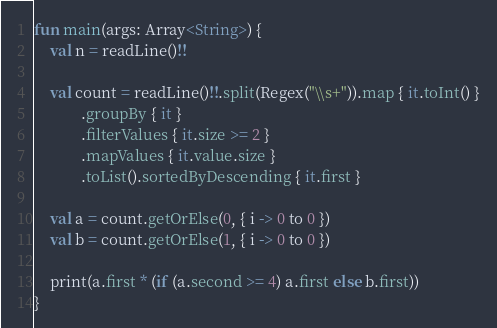<code> <loc_0><loc_0><loc_500><loc_500><_Kotlin_>fun main(args: Array<String>) {
    val n = readLine()!!
 
    val count = readLine()!!.split(Regex("\\s+")).map { it.toInt() }
            .groupBy { it }
            .filterValues { it.size >= 2 }
            .mapValues { it.value.size }
            .toList().sortedByDescending { it.first }

    val a = count.getOrElse(0, { i -> 0 to 0 })
    val b = count.getOrElse(1, { i -> 0 to 0 })
 
    print(a.first * (if (a.second >= 4) a.first else b.first))
}</code> 